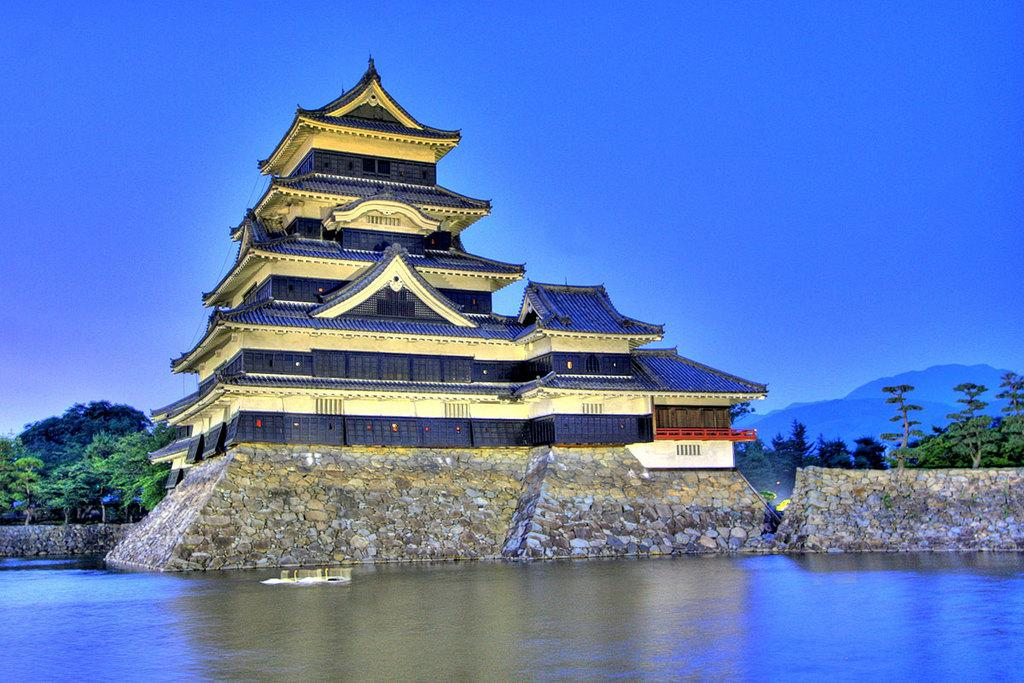What is present in the front of the image? There is water in the front of the image. What can be seen in the background of the image? There is a building, multiple trees, mountains, and the sky visible in the background of the image. What type of substance is being used to cover the trees in the image? There is no substance being used to cover the trees in the image; the trees are visible in their natural state. Can you see a club in the image? There is no club present in the image. 